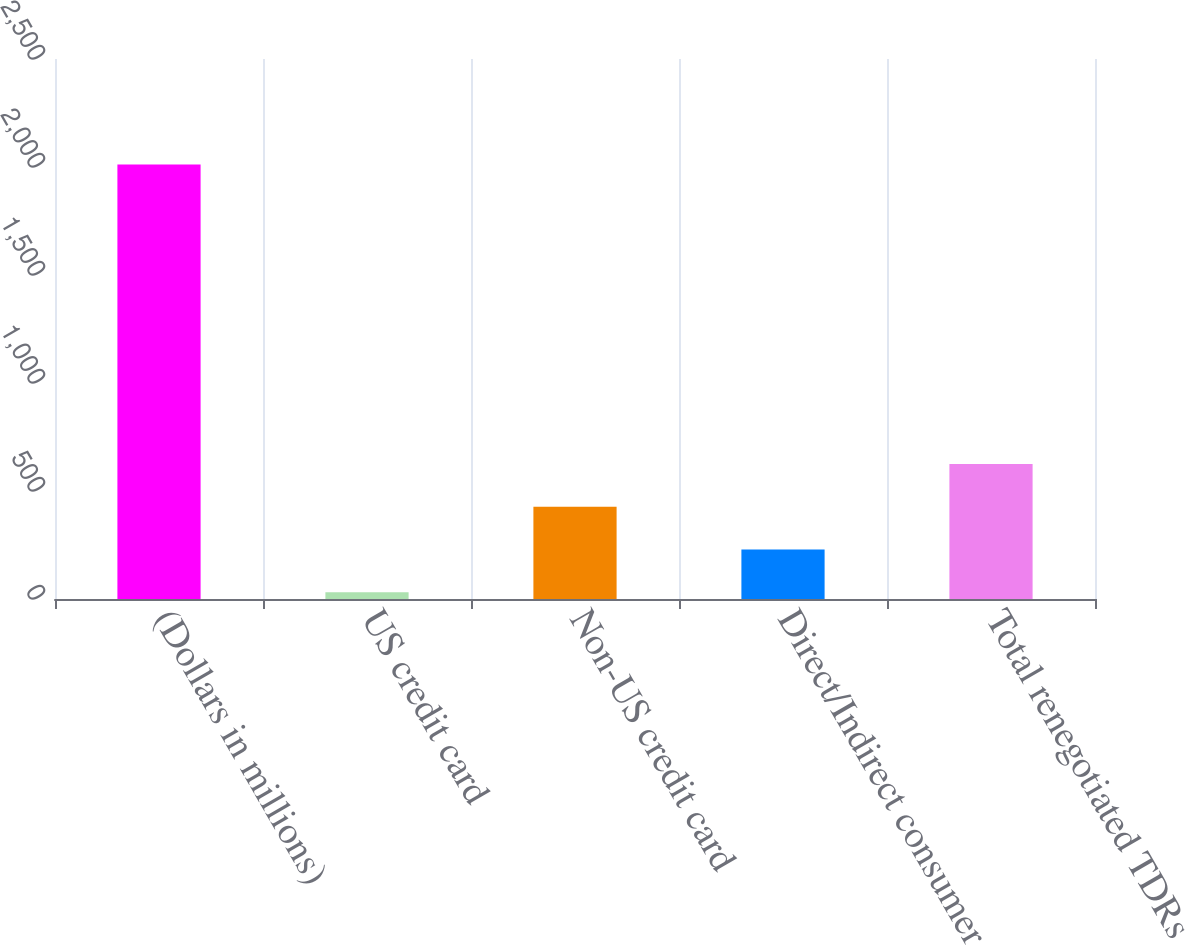Convert chart. <chart><loc_0><loc_0><loc_500><loc_500><bar_chart><fcel>(Dollars in millions)<fcel>US credit card<fcel>Non-US credit card<fcel>Direct/Indirect consumer<fcel>Total renegotiated TDRs<nl><fcel>2012<fcel>31<fcel>427.2<fcel>229.1<fcel>625.3<nl></chart> 